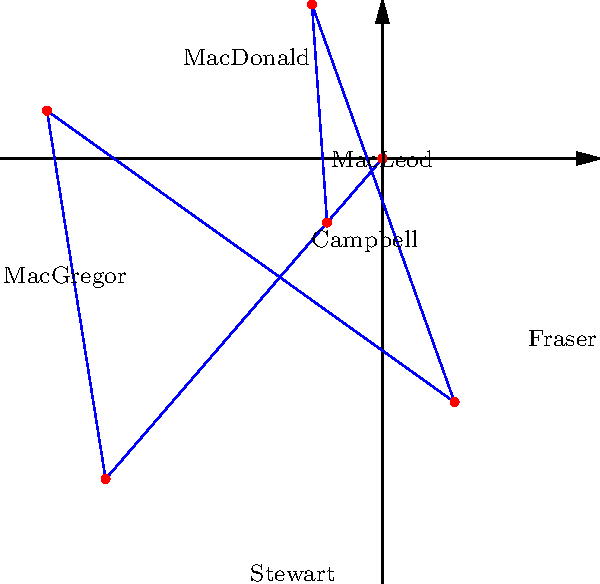The polar rose diagram above represents the territorial spread of six major Scottish clans in medieval times. The radial distance from the center indicates the relative size of each clan's territory. Which clan, according to this diagram, had the largest territory during this period? To determine which clan had the largest territory, we need to compare the radial distances from the center for each clan:

1. MacLeod: approximately 3 units
2. Campbell: approximately 4 units
3. MacDonald: approximately 2 units
4. Fraser: approximately 5 units
5. MacGregor: approximately 3 units
6. Stewart: approximately 4 units

The clan with the largest radial distance represents the largest territory. In this case, the Fraser clan has the longest radial distance of approximately 5 units.

It's important to note that this diagram is a simplified representation and may not accurately reflect the exact historical territorial sizes. However, for the purposes of this question, we are interpreting the radial distances as indicators of relative territory size.
Answer: Fraser 